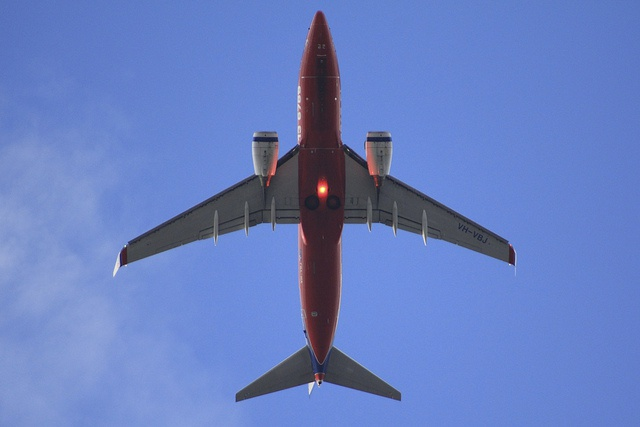Describe the objects in this image and their specific colors. I can see a airplane in gray, black, and maroon tones in this image. 